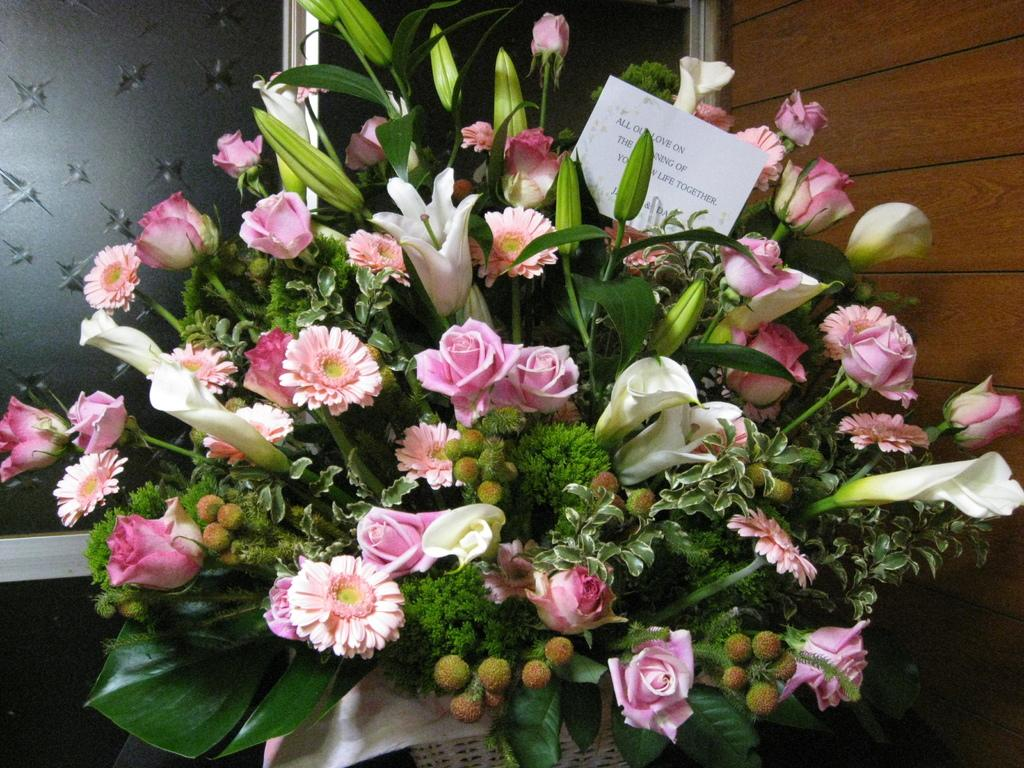What is the main subject of the image? The main subject of the image is a flower bouquet. Is there any accompanying item with the flower bouquet? Yes, there is a card in the image. What colors are the flowers in the bouquet? The flowers are in white and pink colors. Can you describe the background of the image? The background of the image is brown and grey. What type of zinc is present in the image? There is no zinc present in the image. Can you tell me which actor is holding the flower bouquet in the image? There is no actor present in the image, as it only features a flower bouquet and a card. 